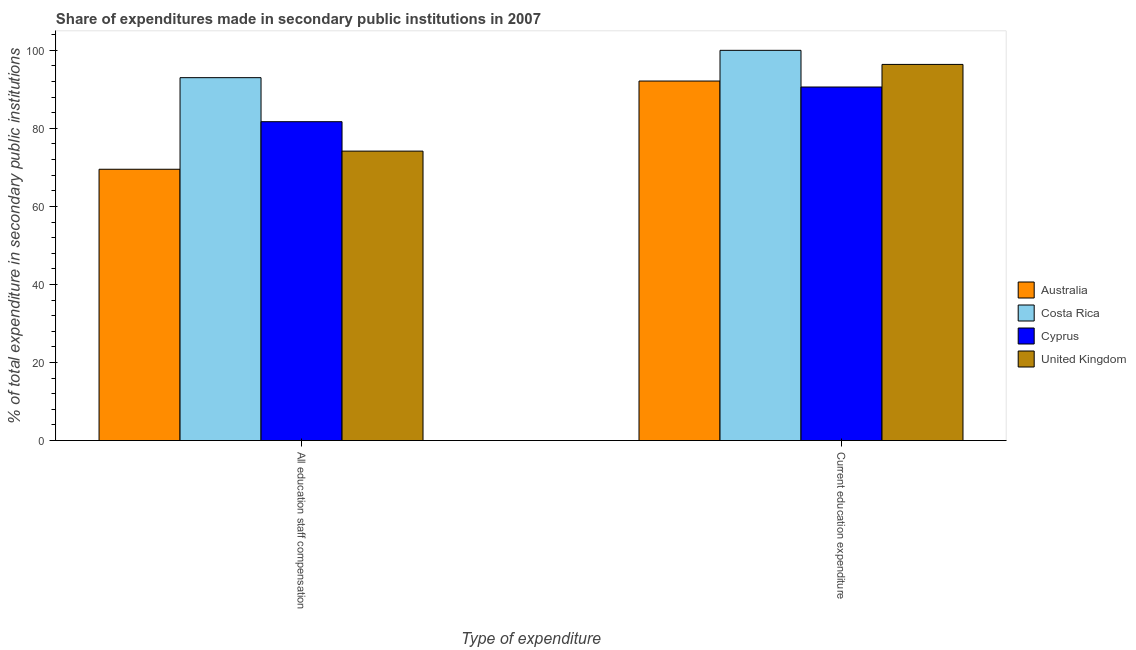How many different coloured bars are there?
Offer a very short reply. 4. How many groups of bars are there?
Ensure brevity in your answer.  2. How many bars are there on the 1st tick from the right?
Give a very brief answer. 4. What is the label of the 1st group of bars from the left?
Offer a terse response. All education staff compensation. What is the expenditure in staff compensation in Costa Rica?
Offer a very short reply. 93. Across all countries, what is the minimum expenditure in staff compensation?
Keep it short and to the point. 69.53. What is the total expenditure in education in the graph?
Keep it short and to the point. 379.12. What is the difference between the expenditure in education in Australia and that in Costa Rica?
Your answer should be compact. -7.87. What is the difference between the expenditure in education in Australia and the expenditure in staff compensation in Cyprus?
Your answer should be compact. 10.42. What is the average expenditure in staff compensation per country?
Ensure brevity in your answer.  79.6. What is the difference between the expenditure in staff compensation and expenditure in education in United Kingdom?
Offer a terse response. -22.22. What is the ratio of the expenditure in education in Cyprus to that in Costa Rica?
Make the answer very short. 0.91. Is the expenditure in education in Cyprus less than that in Australia?
Your answer should be compact. Yes. In how many countries, is the expenditure in education greater than the average expenditure in education taken over all countries?
Give a very brief answer. 2. What does the 3rd bar from the left in All education staff compensation represents?
Give a very brief answer. Cyprus. What does the 2nd bar from the right in All education staff compensation represents?
Give a very brief answer. Cyprus. Are all the bars in the graph horizontal?
Give a very brief answer. No. What is the difference between two consecutive major ticks on the Y-axis?
Your response must be concise. 20. Are the values on the major ticks of Y-axis written in scientific E-notation?
Your answer should be very brief. No. Does the graph contain any zero values?
Offer a very short reply. No. How are the legend labels stacked?
Your answer should be compact. Vertical. What is the title of the graph?
Offer a terse response. Share of expenditures made in secondary public institutions in 2007. What is the label or title of the X-axis?
Provide a short and direct response. Type of expenditure. What is the label or title of the Y-axis?
Your response must be concise. % of total expenditure in secondary public institutions. What is the % of total expenditure in secondary public institutions in Australia in All education staff compensation?
Your answer should be very brief. 69.53. What is the % of total expenditure in secondary public institutions in Costa Rica in All education staff compensation?
Provide a succinct answer. 93. What is the % of total expenditure in secondary public institutions in Cyprus in All education staff compensation?
Give a very brief answer. 81.71. What is the % of total expenditure in secondary public institutions of United Kingdom in All education staff compensation?
Offer a terse response. 74.18. What is the % of total expenditure in secondary public institutions in Australia in Current education expenditure?
Keep it short and to the point. 92.13. What is the % of total expenditure in secondary public institutions in Costa Rica in Current education expenditure?
Your answer should be compact. 100. What is the % of total expenditure in secondary public institutions of Cyprus in Current education expenditure?
Offer a very short reply. 90.6. What is the % of total expenditure in secondary public institutions of United Kingdom in Current education expenditure?
Your answer should be very brief. 96.39. Across all Type of expenditure, what is the maximum % of total expenditure in secondary public institutions of Australia?
Your answer should be compact. 92.13. Across all Type of expenditure, what is the maximum % of total expenditure in secondary public institutions of Costa Rica?
Keep it short and to the point. 100. Across all Type of expenditure, what is the maximum % of total expenditure in secondary public institutions in Cyprus?
Give a very brief answer. 90.6. Across all Type of expenditure, what is the maximum % of total expenditure in secondary public institutions of United Kingdom?
Your answer should be compact. 96.39. Across all Type of expenditure, what is the minimum % of total expenditure in secondary public institutions in Australia?
Your answer should be very brief. 69.53. Across all Type of expenditure, what is the minimum % of total expenditure in secondary public institutions in Costa Rica?
Give a very brief answer. 93. Across all Type of expenditure, what is the minimum % of total expenditure in secondary public institutions of Cyprus?
Give a very brief answer. 81.71. Across all Type of expenditure, what is the minimum % of total expenditure in secondary public institutions in United Kingdom?
Offer a very short reply. 74.18. What is the total % of total expenditure in secondary public institutions of Australia in the graph?
Give a very brief answer. 161.66. What is the total % of total expenditure in secondary public institutions in Costa Rica in the graph?
Provide a succinct answer. 193. What is the total % of total expenditure in secondary public institutions of Cyprus in the graph?
Give a very brief answer. 172.31. What is the total % of total expenditure in secondary public institutions of United Kingdom in the graph?
Provide a short and direct response. 170.57. What is the difference between the % of total expenditure in secondary public institutions in Australia in All education staff compensation and that in Current education expenditure?
Your response must be concise. -22.6. What is the difference between the % of total expenditure in secondary public institutions in Costa Rica in All education staff compensation and that in Current education expenditure?
Your answer should be compact. -7. What is the difference between the % of total expenditure in secondary public institutions in Cyprus in All education staff compensation and that in Current education expenditure?
Your answer should be compact. -8.89. What is the difference between the % of total expenditure in secondary public institutions of United Kingdom in All education staff compensation and that in Current education expenditure?
Give a very brief answer. -22.22. What is the difference between the % of total expenditure in secondary public institutions in Australia in All education staff compensation and the % of total expenditure in secondary public institutions in Costa Rica in Current education expenditure?
Provide a succinct answer. -30.47. What is the difference between the % of total expenditure in secondary public institutions in Australia in All education staff compensation and the % of total expenditure in secondary public institutions in Cyprus in Current education expenditure?
Provide a short and direct response. -21.07. What is the difference between the % of total expenditure in secondary public institutions of Australia in All education staff compensation and the % of total expenditure in secondary public institutions of United Kingdom in Current education expenditure?
Your answer should be compact. -26.86. What is the difference between the % of total expenditure in secondary public institutions of Costa Rica in All education staff compensation and the % of total expenditure in secondary public institutions of Cyprus in Current education expenditure?
Your answer should be very brief. 2.4. What is the difference between the % of total expenditure in secondary public institutions in Costa Rica in All education staff compensation and the % of total expenditure in secondary public institutions in United Kingdom in Current education expenditure?
Provide a succinct answer. -3.39. What is the difference between the % of total expenditure in secondary public institutions in Cyprus in All education staff compensation and the % of total expenditure in secondary public institutions in United Kingdom in Current education expenditure?
Make the answer very short. -14.68. What is the average % of total expenditure in secondary public institutions of Australia per Type of expenditure?
Offer a very short reply. 80.83. What is the average % of total expenditure in secondary public institutions of Costa Rica per Type of expenditure?
Your response must be concise. 96.5. What is the average % of total expenditure in secondary public institutions of Cyprus per Type of expenditure?
Your response must be concise. 86.16. What is the average % of total expenditure in secondary public institutions in United Kingdom per Type of expenditure?
Offer a terse response. 85.28. What is the difference between the % of total expenditure in secondary public institutions of Australia and % of total expenditure in secondary public institutions of Costa Rica in All education staff compensation?
Make the answer very short. -23.47. What is the difference between the % of total expenditure in secondary public institutions of Australia and % of total expenditure in secondary public institutions of Cyprus in All education staff compensation?
Ensure brevity in your answer.  -12.19. What is the difference between the % of total expenditure in secondary public institutions of Australia and % of total expenditure in secondary public institutions of United Kingdom in All education staff compensation?
Provide a short and direct response. -4.65. What is the difference between the % of total expenditure in secondary public institutions of Costa Rica and % of total expenditure in secondary public institutions of Cyprus in All education staff compensation?
Keep it short and to the point. 11.28. What is the difference between the % of total expenditure in secondary public institutions in Costa Rica and % of total expenditure in secondary public institutions in United Kingdom in All education staff compensation?
Your answer should be compact. 18.82. What is the difference between the % of total expenditure in secondary public institutions in Cyprus and % of total expenditure in secondary public institutions in United Kingdom in All education staff compensation?
Make the answer very short. 7.54. What is the difference between the % of total expenditure in secondary public institutions of Australia and % of total expenditure in secondary public institutions of Costa Rica in Current education expenditure?
Make the answer very short. -7.87. What is the difference between the % of total expenditure in secondary public institutions of Australia and % of total expenditure in secondary public institutions of Cyprus in Current education expenditure?
Provide a short and direct response. 1.53. What is the difference between the % of total expenditure in secondary public institutions in Australia and % of total expenditure in secondary public institutions in United Kingdom in Current education expenditure?
Ensure brevity in your answer.  -4.26. What is the difference between the % of total expenditure in secondary public institutions in Costa Rica and % of total expenditure in secondary public institutions in Cyprus in Current education expenditure?
Your answer should be very brief. 9.4. What is the difference between the % of total expenditure in secondary public institutions in Costa Rica and % of total expenditure in secondary public institutions in United Kingdom in Current education expenditure?
Provide a succinct answer. 3.61. What is the difference between the % of total expenditure in secondary public institutions in Cyprus and % of total expenditure in secondary public institutions in United Kingdom in Current education expenditure?
Make the answer very short. -5.79. What is the ratio of the % of total expenditure in secondary public institutions of Australia in All education staff compensation to that in Current education expenditure?
Your response must be concise. 0.75. What is the ratio of the % of total expenditure in secondary public institutions in Cyprus in All education staff compensation to that in Current education expenditure?
Offer a very short reply. 0.9. What is the ratio of the % of total expenditure in secondary public institutions of United Kingdom in All education staff compensation to that in Current education expenditure?
Make the answer very short. 0.77. What is the difference between the highest and the second highest % of total expenditure in secondary public institutions in Australia?
Your response must be concise. 22.6. What is the difference between the highest and the second highest % of total expenditure in secondary public institutions in Costa Rica?
Ensure brevity in your answer.  7. What is the difference between the highest and the second highest % of total expenditure in secondary public institutions in Cyprus?
Provide a succinct answer. 8.89. What is the difference between the highest and the second highest % of total expenditure in secondary public institutions of United Kingdom?
Give a very brief answer. 22.22. What is the difference between the highest and the lowest % of total expenditure in secondary public institutions of Australia?
Provide a succinct answer. 22.6. What is the difference between the highest and the lowest % of total expenditure in secondary public institutions in Costa Rica?
Your response must be concise. 7. What is the difference between the highest and the lowest % of total expenditure in secondary public institutions in Cyprus?
Your answer should be very brief. 8.89. What is the difference between the highest and the lowest % of total expenditure in secondary public institutions in United Kingdom?
Offer a very short reply. 22.22. 